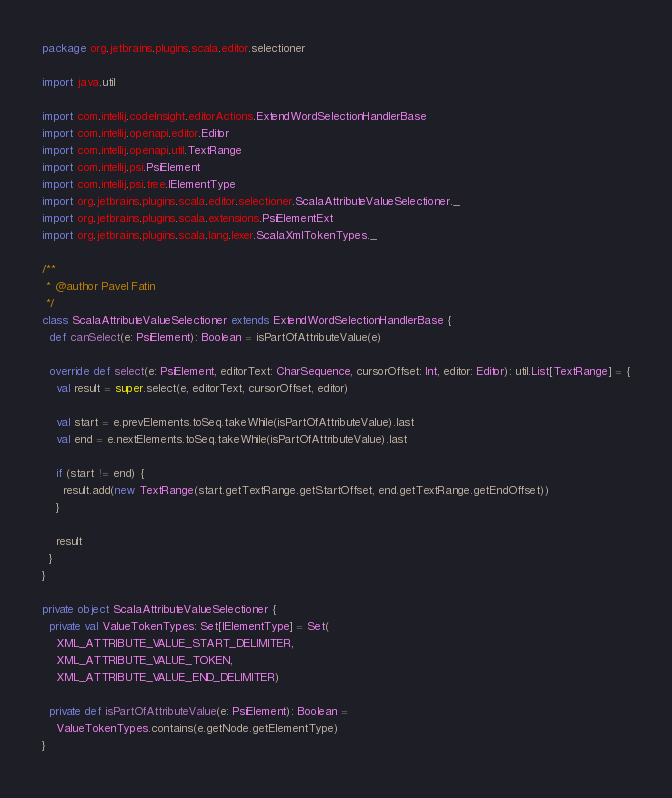<code> <loc_0><loc_0><loc_500><loc_500><_Scala_>package org.jetbrains.plugins.scala.editor.selectioner

import java.util

import com.intellij.codeInsight.editorActions.ExtendWordSelectionHandlerBase
import com.intellij.openapi.editor.Editor
import com.intellij.openapi.util.TextRange
import com.intellij.psi.PsiElement
import com.intellij.psi.tree.IElementType
import org.jetbrains.plugins.scala.editor.selectioner.ScalaAttributeValueSelectioner._
import org.jetbrains.plugins.scala.extensions.PsiElementExt
import org.jetbrains.plugins.scala.lang.lexer.ScalaXmlTokenTypes._

/**
 * @author Pavel Fatin
 */
class ScalaAttributeValueSelectioner extends ExtendWordSelectionHandlerBase {
  def canSelect(e: PsiElement): Boolean = isPartOfAttributeValue(e)

  override def select(e: PsiElement, editorText: CharSequence, cursorOffset: Int, editor: Editor): util.List[TextRange] = {
    val result = super.select(e, editorText, cursorOffset, editor)

    val start = e.prevElements.toSeq.takeWhile(isPartOfAttributeValue).last
    val end = e.nextElements.toSeq.takeWhile(isPartOfAttributeValue).last

    if (start != end) {
      result.add(new TextRange(start.getTextRange.getStartOffset, end.getTextRange.getEndOffset))
    }

    result
  }
}

private object ScalaAttributeValueSelectioner {
  private val ValueTokenTypes: Set[IElementType] = Set(
    XML_ATTRIBUTE_VALUE_START_DELIMITER,
    XML_ATTRIBUTE_VALUE_TOKEN,
    XML_ATTRIBUTE_VALUE_END_DELIMITER)

  private def isPartOfAttributeValue(e: PsiElement): Boolean =
    ValueTokenTypes.contains(e.getNode.getElementType)
}</code> 